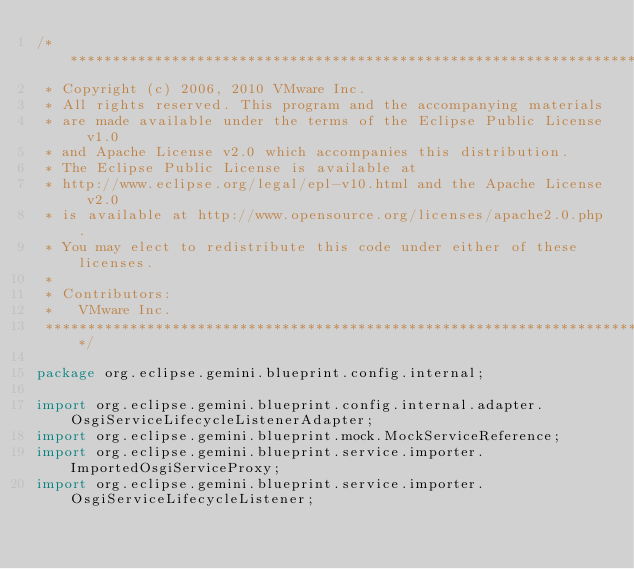<code> <loc_0><loc_0><loc_500><loc_500><_Java_>/******************************************************************************
 * Copyright (c) 2006, 2010 VMware Inc.
 * All rights reserved. This program and the accompanying materials
 * are made available under the terms of the Eclipse Public License v1.0
 * and Apache License v2.0 which accompanies this distribution. 
 * The Eclipse Public License is available at 
 * http://www.eclipse.org/legal/epl-v10.html and the Apache License v2.0
 * is available at http://www.opensource.org/licenses/apache2.0.php.
 * You may elect to redistribute this code under either of these licenses. 
 *
 * Contributors:
 *   VMware Inc.
 *****************************************************************************/

package org.eclipse.gemini.blueprint.config.internal;

import org.eclipse.gemini.blueprint.config.internal.adapter.OsgiServiceLifecycleListenerAdapter;
import org.eclipse.gemini.blueprint.mock.MockServiceReference;
import org.eclipse.gemini.blueprint.service.importer.ImportedOsgiServiceProxy;
import org.eclipse.gemini.blueprint.service.importer.OsgiServiceLifecycleListener;</code> 